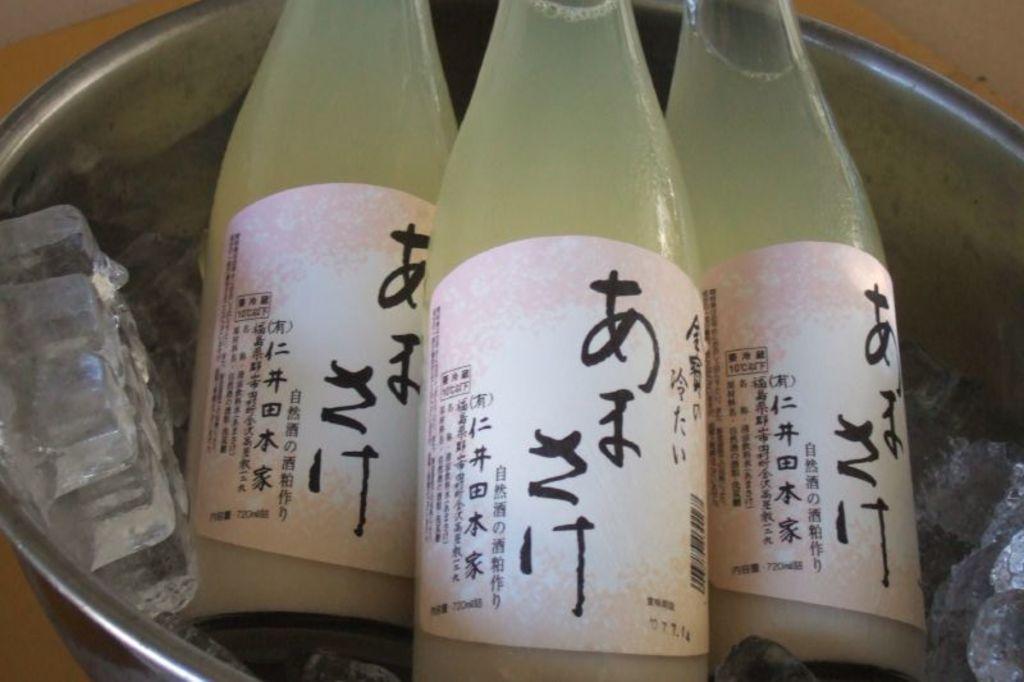Describe this image in one or two sentences. this picture shows bottles in a vessel with ice 